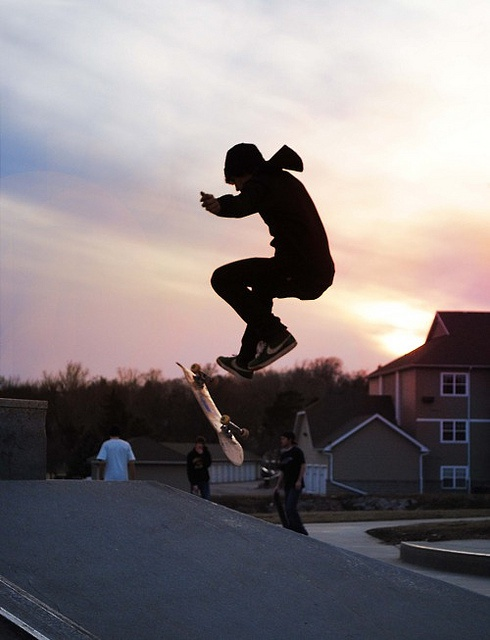Describe the objects in this image and their specific colors. I can see people in lightgray, black, maroon, and pink tones, skateboard in lightgray, black, gray, brown, and maroon tones, people in lightgray and black tones, people in lightgray, gray, black, and blue tones, and people in lightgray and black tones in this image. 